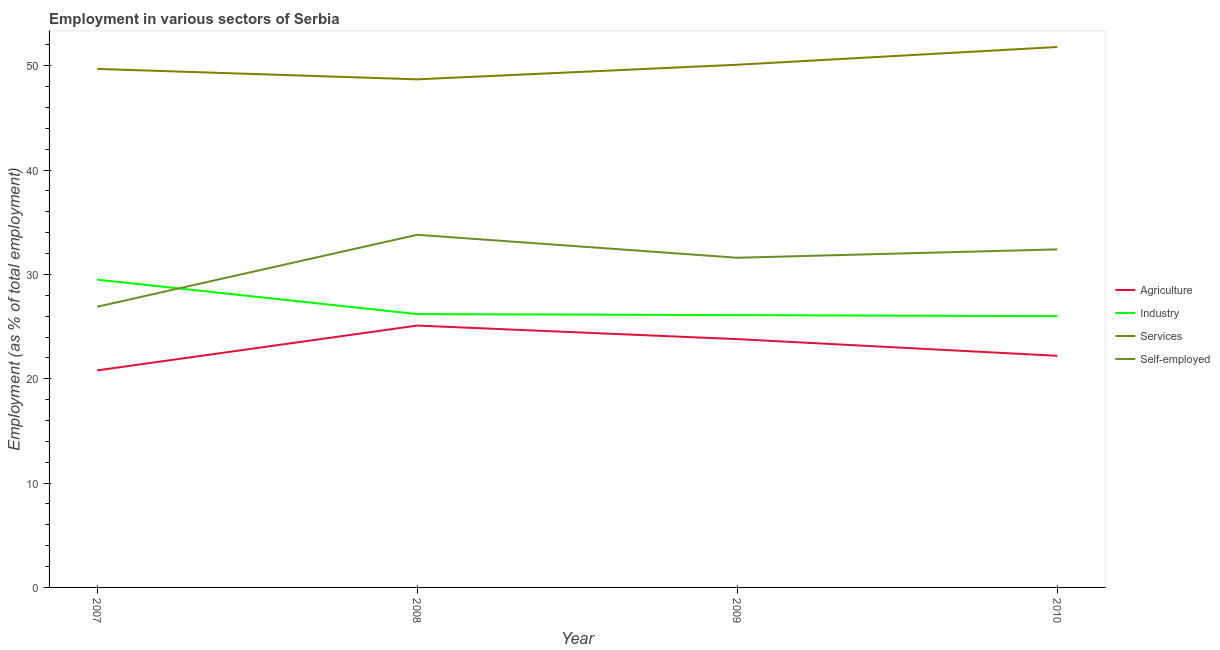Does the line corresponding to percentage of workers in services intersect with the line corresponding to percentage of workers in agriculture?
Keep it short and to the point. No. Is the number of lines equal to the number of legend labels?
Offer a terse response. Yes. Across all years, what is the maximum percentage of self employed workers?
Ensure brevity in your answer.  33.8. Across all years, what is the minimum percentage of self employed workers?
Provide a short and direct response. 26.9. What is the total percentage of workers in industry in the graph?
Your answer should be compact. 107.8. What is the difference between the percentage of workers in industry in 2008 and that in 2009?
Ensure brevity in your answer.  0.1. What is the difference between the percentage of workers in industry in 2007 and the percentage of workers in services in 2010?
Provide a short and direct response. -22.3. What is the average percentage of workers in agriculture per year?
Provide a succinct answer. 22.97. In the year 2010, what is the difference between the percentage of workers in services and percentage of workers in industry?
Your answer should be very brief. 25.8. What is the ratio of the percentage of workers in industry in 2008 to that in 2009?
Give a very brief answer. 1. Is the difference between the percentage of self employed workers in 2008 and 2009 greater than the difference between the percentage of workers in agriculture in 2008 and 2009?
Offer a very short reply. Yes. What is the difference between the highest and the second highest percentage of self employed workers?
Make the answer very short. 1.4. What is the difference between the highest and the lowest percentage of workers in industry?
Make the answer very short. 3.5. Is the sum of the percentage of workers in industry in 2008 and 2010 greater than the maximum percentage of self employed workers across all years?
Ensure brevity in your answer.  Yes. Is it the case that in every year, the sum of the percentage of workers in industry and percentage of self employed workers is greater than the sum of percentage of workers in agriculture and percentage of workers in services?
Your answer should be very brief. Yes. Does the percentage of workers in services monotonically increase over the years?
Offer a terse response. No. What is the difference between two consecutive major ticks on the Y-axis?
Your answer should be compact. 10. Does the graph contain any zero values?
Your answer should be compact. No. Does the graph contain grids?
Offer a very short reply. No. Where does the legend appear in the graph?
Provide a short and direct response. Center right. What is the title of the graph?
Provide a succinct answer. Employment in various sectors of Serbia. Does "Services" appear as one of the legend labels in the graph?
Your answer should be very brief. Yes. What is the label or title of the Y-axis?
Provide a short and direct response. Employment (as % of total employment). What is the Employment (as % of total employment) in Agriculture in 2007?
Keep it short and to the point. 20.8. What is the Employment (as % of total employment) of Industry in 2007?
Offer a very short reply. 29.5. What is the Employment (as % of total employment) of Services in 2007?
Provide a short and direct response. 49.7. What is the Employment (as % of total employment) of Self-employed in 2007?
Offer a terse response. 26.9. What is the Employment (as % of total employment) of Agriculture in 2008?
Make the answer very short. 25.1. What is the Employment (as % of total employment) of Industry in 2008?
Offer a terse response. 26.2. What is the Employment (as % of total employment) of Services in 2008?
Provide a succinct answer. 48.7. What is the Employment (as % of total employment) of Self-employed in 2008?
Your response must be concise. 33.8. What is the Employment (as % of total employment) of Agriculture in 2009?
Offer a terse response. 23.8. What is the Employment (as % of total employment) in Industry in 2009?
Provide a short and direct response. 26.1. What is the Employment (as % of total employment) in Services in 2009?
Offer a very short reply. 50.1. What is the Employment (as % of total employment) of Self-employed in 2009?
Keep it short and to the point. 31.6. What is the Employment (as % of total employment) in Agriculture in 2010?
Offer a terse response. 22.2. What is the Employment (as % of total employment) of Services in 2010?
Ensure brevity in your answer.  51.8. What is the Employment (as % of total employment) in Self-employed in 2010?
Offer a terse response. 32.4. Across all years, what is the maximum Employment (as % of total employment) of Agriculture?
Your answer should be compact. 25.1. Across all years, what is the maximum Employment (as % of total employment) in Industry?
Your response must be concise. 29.5. Across all years, what is the maximum Employment (as % of total employment) of Services?
Provide a short and direct response. 51.8. Across all years, what is the maximum Employment (as % of total employment) in Self-employed?
Make the answer very short. 33.8. Across all years, what is the minimum Employment (as % of total employment) in Agriculture?
Keep it short and to the point. 20.8. Across all years, what is the minimum Employment (as % of total employment) in Services?
Ensure brevity in your answer.  48.7. Across all years, what is the minimum Employment (as % of total employment) of Self-employed?
Offer a very short reply. 26.9. What is the total Employment (as % of total employment) in Agriculture in the graph?
Your answer should be very brief. 91.9. What is the total Employment (as % of total employment) of Industry in the graph?
Your answer should be very brief. 107.8. What is the total Employment (as % of total employment) of Services in the graph?
Offer a terse response. 200.3. What is the total Employment (as % of total employment) of Self-employed in the graph?
Make the answer very short. 124.7. What is the difference between the Employment (as % of total employment) in Agriculture in 2007 and that in 2008?
Keep it short and to the point. -4.3. What is the difference between the Employment (as % of total employment) of Services in 2007 and that in 2009?
Offer a terse response. -0.4. What is the difference between the Employment (as % of total employment) in Self-employed in 2007 and that in 2009?
Ensure brevity in your answer.  -4.7. What is the difference between the Employment (as % of total employment) of Industry in 2007 and that in 2010?
Make the answer very short. 3.5. What is the difference between the Employment (as % of total employment) of Services in 2007 and that in 2010?
Provide a short and direct response. -2.1. What is the difference between the Employment (as % of total employment) in Self-employed in 2007 and that in 2010?
Offer a very short reply. -5.5. What is the difference between the Employment (as % of total employment) of Services in 2008 and that in 2009?
Offer a terse response. -1.4. What is the difference between the Employment (as % of total employment) of Agriculture in 2008 and that in 2010?
Keep it short and to the point. 2.9. What is the difference between the Employment (as % of total employment) of Industry in 2008 and that in 2010?
Provide a succinct answer. 0.2. What is the difference between the Employment (as % of total employment) in Services in 2008 and that in 2010?
Give a very brief answer. -3.1. What is the difference between the Employment (as % of total employment) of Self-employed in 2008 and that in 2010?
Ensure brevity in your answer.  1.4. What is the difference between the Employment (as % of total employment) of Agriculture in 2009 and that in 2010?
Your answer should be compact. 1.6. What is the difference between the Employment (as % of total employment) of Industry in 2009 and that in 2010?
Your response must be concise. 0.1. What is the difference between the Employment (as % of total employment) in Self-employed in 2009 and that in 2010?
Give a very brief answer. -0.8. What is the difference between the Employment (as % of total employment) in Agriculture in 2007 and the Employment (as % of total employment) in Industry in 2008?
Your response must be concise. -5.4. What is the difference between the Employment (as % of total employment) of Agriculture in 2007 and the Employment (as % of total employment) of Services in 2008?
Offer a very short reply. -27.9. What is the difference between the Employment (as % of total employment) of Agriculture in 2007 and the Employment (as % of total employment) of Self-employed in 2008?
Give a very brief answer. -13. What is the difference between the Employment (as % of total employment) of Industry in 2007 and the Employment (as % of total employment) of Services in 2008?
Ensure brevity in your answer.  -19.2. What is the difference between the Employment (as % of total employment) of Industry in 2007 and the Employment (as % of total employment) of Self-employed in 2008?
Your answer should be very brief. -4.3. What is the difference between the Employment (as % of total employment) of Agriculture in 2007 and the Employment (as % of total employment) of Industry in 2009?
Your answer should be very brief. -5.3. What is the difference between the Employment (as % of total employment) of Agriculture in 2007 and the Employment (as % of total employment) of Services in 2009?
Provide a short and direct response. -29.3. What is the difference between the Employment (as % of total employment) in Industry in 2007 and the Employment (as % of total employment) in Services in 2009?
Ensure brevity in your answer.  -20.6. What is the difference between the Employment (as % of total employment) in Industry in 2007 and the Employment (as % of total employment) in Self-employed in 2009?
Offer a terse response. -2.1. What is the difference between the Employment (as % of total employment) of Services in 2007 and the Employment (as % of total employment) of Self-employed in 2009?
Offer a very short reply. 18.1. What is the difference between the Employment (as % of total employment) of Agriculture in 2007 and the Employment (as % of total employment) of Industry in 2010?
Make the answer very short. -5.2. What is the difference between the Employment (as % of total employment) in Agriculture in 2007 and the Employment (as % of total employment) in Services in 2010?
Offer a very short reply. -31. What is the difference between the Employment (as % of total employment) in Agriculture in 2007 and the Employment (as % of total employment) in Self-employed in 2010?
Offer a very short reply. -11.6. What is the difference between the Employment (as % of total employment) in Industry in 2007 and the Employment (as % of total employment) in Services in 2010?
Ensure brevity in your answer.  -22.3. What is the difference between the Employment (as % of total employment) in Industry in 2007 and the Employment (as % of total employment) in Self-employed in 2010?
Give a very brief answer. -2.9. What is the difference between the Employment (as % of total employment) in Services in 2007 and the Employment (as % of total employment) in Self-employed in 2010?
Ensure brevity in your answer.  17.3. What is the difference between the Employment (as % of total employment) in Industry in 2008 and the Employment (as % of total employment) in Services in 2009?
Your answer should be very brief. -23.9. What is the difference between the Employment (as % of total employment) in Agriculture in 2008 and the Employment (as % of total employment) in Industry in 2010?
Offer a terse response. -0.9. What is the difference between the Employment (as % of total employment) in Agriculture in 2008 and the Employment (as % of total employment) in Services in 2010?
Provide a succinct answer. -26.7. What is the difference between the Employment (as % of total employment) in Industry in 2008 and the Employment (as % of total employment) in Services in 2010?
Ensure brevity in your answer.  -25.6. What is the difference between the Employment (as % of total employment) in Services in 2008 and the Employment (as % of total employment) in Self-employed in 2010?
Provide a succinct answer. 16.3. What is the difference between the Employment (as % of total employment) of Agriculture in 2009 and the Employment (as % of total employment) of Services in 2010?
Keep it short and to the point. -28. What is the difference between the Employment (as % of total employment) in Industry in 2009 and the Employment (as % of total employment) in Services in 2010?
Keep it short and to the point. -25.7. What is the difference between the Employment (as % of total employment) of Industry in 2009 and the Employment (as % of total employment) of Self-employed in 2010?
Offer a terse response. -6.3. What is the difference between the Employment (as % of total employment) of Services in 2009 and the Employment (as % of total employment) of Self-employed in 2010?
Provide a short and direct response. 17.7. What is the average Employment (as % of total employment) in Agriculture per year?
Your answer should be very brief. 22.98. What is the average Employment (as % of total employment) in Industry per year?
Your response must be concise. 26.95. What is the average Employment (as % of total employment) in Services per year?
Offer a very short reply. 50.08. What is the average Employment (as % of total employment) of Self-employed per year?
Keep it short and to the point. 31.18. In the year 2007, what is the difference between the Employment (as % of total employment) of Agriculture and Employment (as % of total employment) of Industry?
Offer a terse response. -8.7. In the year 2007, what is the difference between the Employment (as % of total employment) in Agriculture and Employment (as % of total employment) in Services?
Provide a short and direct response. -28.9. In the year 2007, what is the difference between the Employment (as % of total employment) of Industry and Employment (as % of total employment) of Services?
Your answer should be compact. -20.2. In the year 2007, what is the difference between the Employment (as % of total employment) of Industry and Employment (as % of total employment) of Self-employed?
Offer a very short reply. 2.6. In the year 2007, what is the difference between the Employment (as % of total employment) of Services and Employment (as % of total employment) of Self-employed?
Your answer should be very brief. 22.8. In the year 2008, what is the difference between the Employment (as % of total employment) of Agriculture and Employment (as % of total employment) of Industry?
Offer a terse response. -1.1. In the year 2008, what is the difference between the Employment (as % of total employment) of Agriculture and Employment (as % of total employment) of Services?
Offer a very short reply. -23.6. In the year 2008, what is the difference between the Employment (as % of total employment) of Industry and Employment (as % of total employment) of Services?
Make the answer very short. -22.5. In the year 2008, what is the difference between the Employment (as % of total employment) of Industry and Employment (as % of total employment) of Self-employed?
Give a very brief answer. -7.6. In the year 2009, what is the difference between the Employment (as % of total employment) of Agriculture and Employment (as % of total employment) of Services?
Your answer should be very brief. -26.3. In the year 2009, what is the difference between the Employment (as % of total employment) in Agriculture and Employment (as % of total employment) in Self-employed?
Your answer should be very brief. -7.8. In the year 2009, what is the difference between the Employment (as % of total employment) of Industry and Employment (as % of total employment) of Services?
Make the answer very short. -24. In the year 2009, what is the difference between the Employment (as % of total employment) of Industry and Employment (as % of total employment) of Self-employed?
Provide a short and direct response. -5.5. In the year 2010, what is the difference between the Employment (as % of total employment) in Agriculture and Employment (as % of total employment) in Services?
Keep it short and to the point. -29.6. In the year 2010, what is the difference between the Employment (as % of total employment) in Agriculture and Employment (as % of total employment) in Self-employed?
Your answer should be compact. -10.2. In the year 2010, what is the difference between the Employment (as % of total employment) of Industry and Employment (as % of total employment) of Services?
Your answer should be very brief. -25.8. In the year 2010, what is the difference between the Employment (as % of total employment) of Industry and Employment (as % of total employment) of Self-employed?
Offer a terse response. -6.4. What is the ratio of the Employment (as % of total employment) in Agriculture in 2007 to that in 2008?
Make the answer very short. 0.83. What is the ratio of the Employment (as % of total employment) in Industry in 2007 to that in 2008?
Give a very brief answer. 1.13. What is the ratio of the Employment (as % of total employment) of Services in 2007 to that in 2008?
Offer a very short reply. 1.02. What is the ratio of the Employment (as % of total employment) of Self-employed in 2007 to that in 2008?
Keep it short and to the point. 0.8. What is the ratio of the Employment (as % of total employment) in Agriculture in 2007 to that in 2009?
Make the answer very short. 0.87. What is the ratio of the Employment (as % of total employment) in Industry in 2007 to that in 2009?
Give a very brief answer. 1.13. What is the ratio of the Employment (as % of total employment) in Self-employed in 2007 to that in 2009?
Keep it short and to the point. 0.85. What is the ratio of the Employment (as % of total employment) of Agriculture in 2007 to that in 2010?
Ensure brevity in your answer.  0.94. What is the ratio of the Employment (as % of total employment) of Industry in 2007 to that in 2010?
Provide a succinct answer. 1.13. What is the ratio of the Employment (as % of total employment) of Services in 2007 to that in 2010?
Your answer should be compact. 0.96. What is the ratio of the Employment (as % of total employment) in Self-employed in 2007 to that in 2010?
Your response must be concise. 0.83. What is the ratio of the Employment (as % of total employment) in Agriculture in 2008 to that in 2009?
Give a very brief answer. 1.05. What is the ratio of the Employment (as % of total employment) in Industry in 2008 to that in 2009?
Give a very brief answer. 1. What is the ratio of the Employment (as % of total employment) of Services in 2008 to that in 2009?
Provide a short and direct response. 0.97. What is the ratio of the Employment (as % of total employment) in Self-employed in 2008 to that in 2009?
Your response must be concise. 1.07. What is the ratio of the Employment (as % of total employment) in Agriculture in 2008 to that in 2010?
Provide a succinct answer. 1.13. What is the ratio of the Employment (as % of total employment) in Industry in 2008 to that in 2010?
Provide a succinct answer. 1.01. What is the ratio of the Employment (as % of total employment) in Services in 2008 to that in 2010?
Offer a terse response. 0.94. What is the ratio of the Employment (as % of total employment) of Self-employed in 2008 to that in 2010?
Provide a succinct answer. 1.04. What is the ratio of the Employment (as % of total employment) of Agriculture in 2009 to that in 2010?
Keep it short and to the point. 1.07. What is the ratio of the Employment (as % of total employment) in Services in 2009 to that in 2010?
Ensure brevity in your answer.  0.97. What is the ratio of the Employment (as % of total employment) of Self-employed in 2009 to that in 2010?
Make the answer very short. 0.98. What is the difference between the highest and the second highest Employment (as % of total employment) of Agriculture?
Ensure brevity in your answer.  1.3. What is the difference between the highest and the second highest Employment (as % of total employment) in Industry?
Give a very brief answer. 3.3. What is the difference between the highest and the lowest Employment (as % of total employment) in Agriculture?
Your answer should be compact. 4.3. What is the difference between the highest and the lowest Employment (as % of total employment) of Industry?
Give a very brief answer. 3.5. What is the difference between the highest and the lowest Employment (as % of total employment) in Services?
Provide a short and direct response. 3.1. 